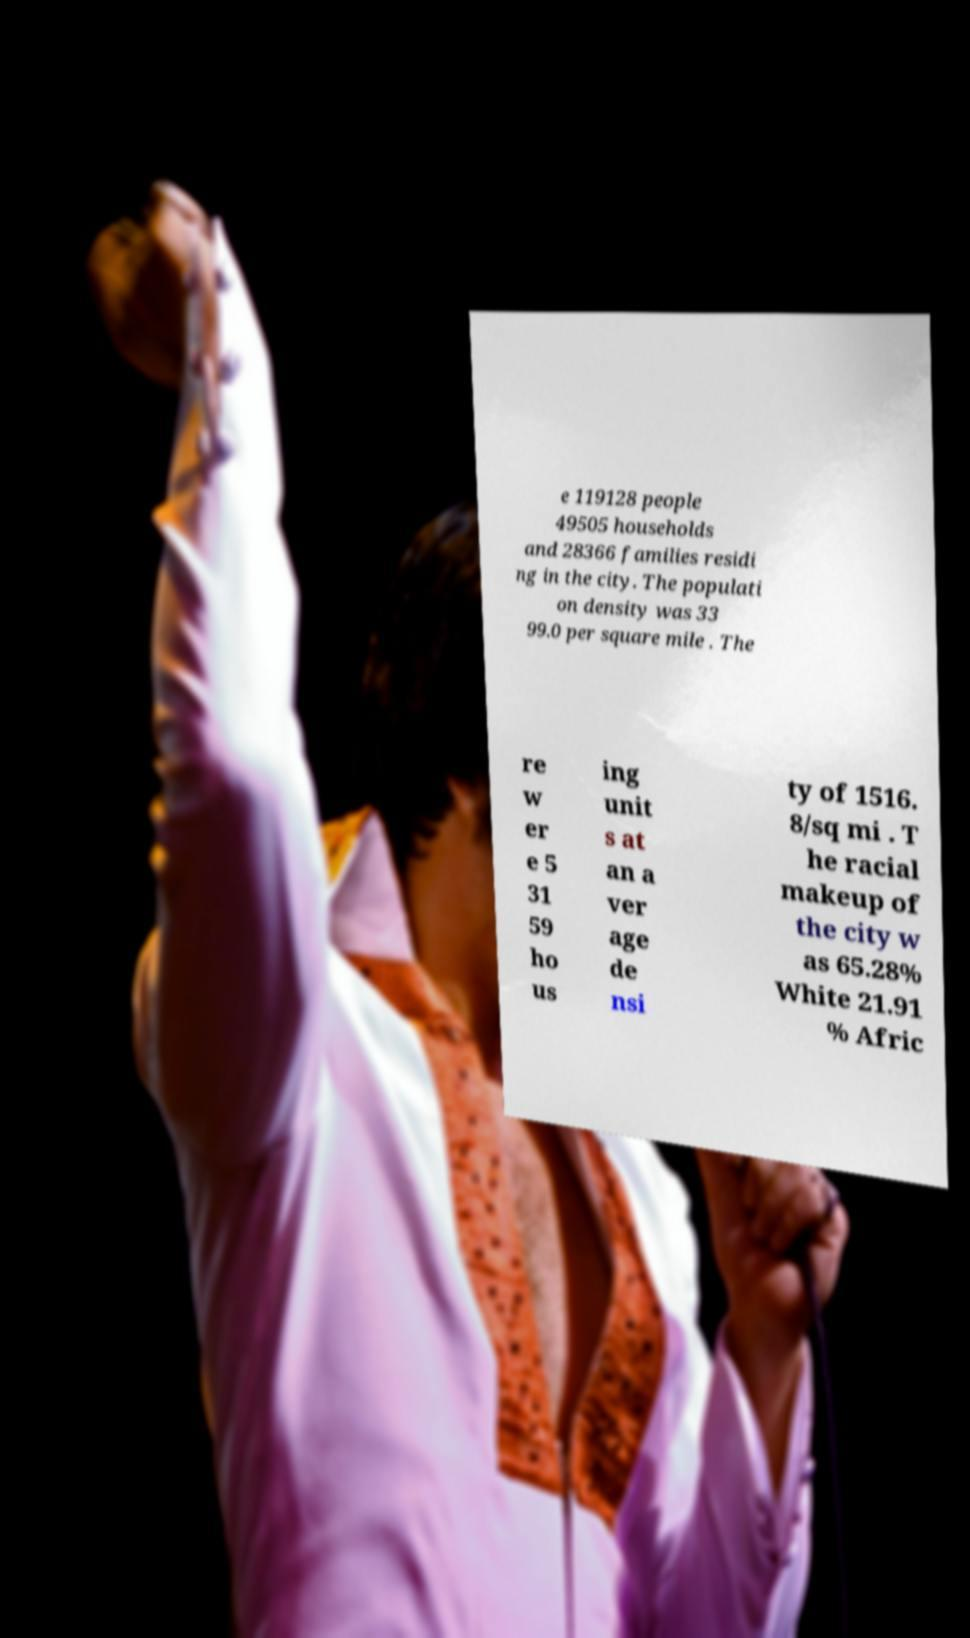Could you extract and type out the text from this image? e 119128 people 49505 households and 28366 families residi ng in the city. The populati on density was 33 99.0 per square mile . The re w er e 5 31 59 ho us ing unit s at an a ver age de nsi ty of 1516. 8/sq mi . T he racial makeup of the city w as 65.28% White 21.91 % Afric 